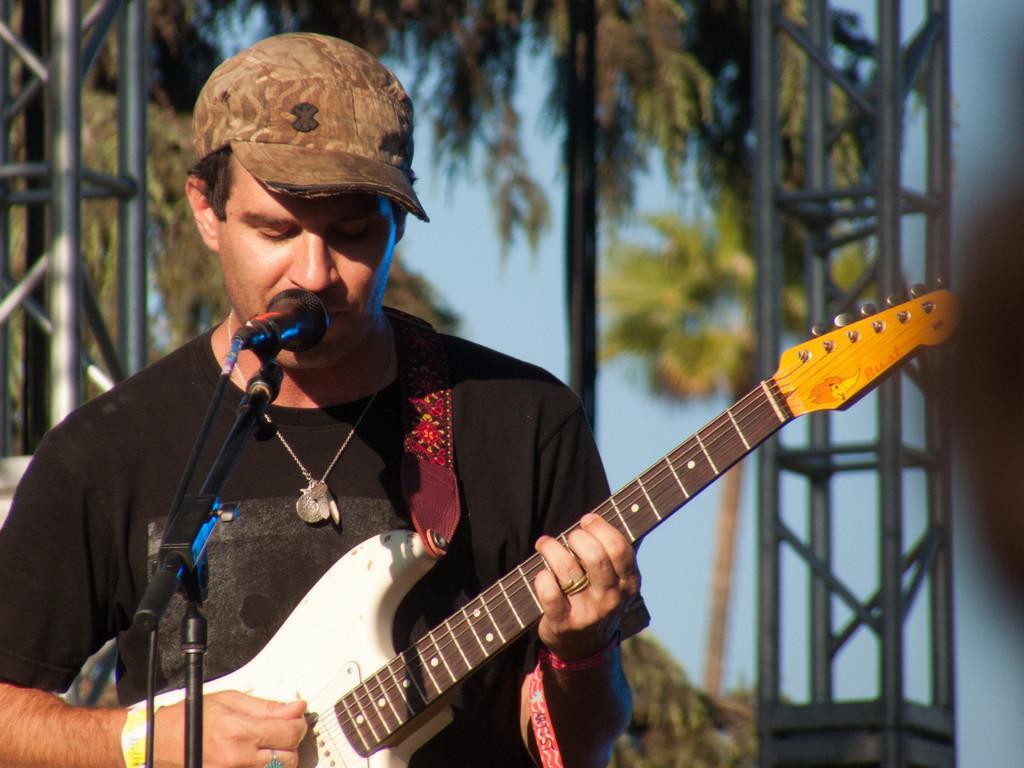Describe this image in one or two sentences. There is a man wearing cap is holding guitar and playing. In front of him there is a mic and mic stand. In the background there are trees, stands and sky. 